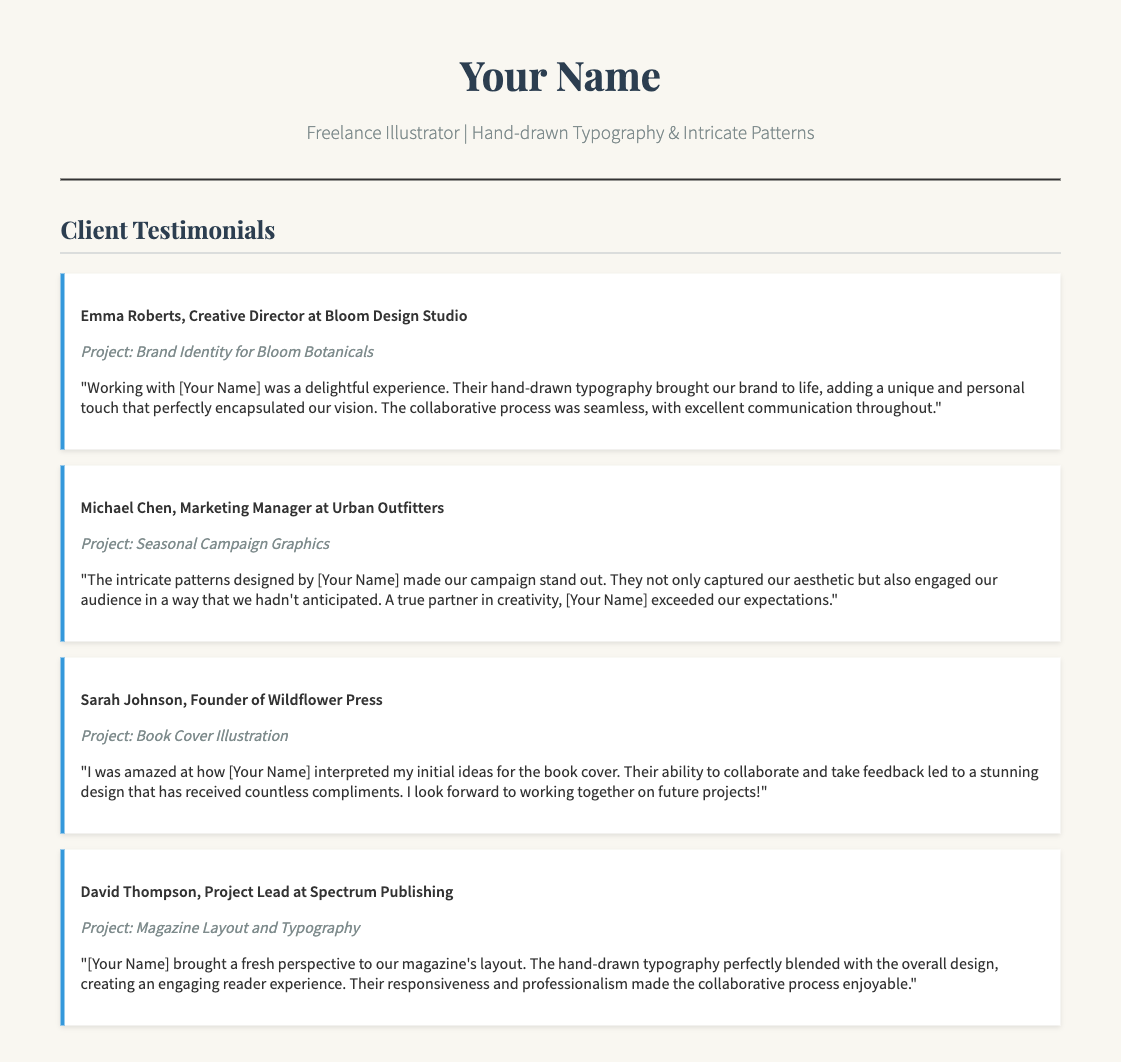what is the name of the first client mentioned? The first client mentioned in the testimonials is Emma Roberts.
Answer: Emma Roberts what is the project associated with Michael Chen? The project associated with Michael Chen is the Seasonal Campaign Graphics.
Answer: Seasonal Campaign Graphics how was the communication described in Emma Roberts' testimonial? Emma Roberts described the communication as excellent throughout the collaborative process.
Answer: excellent what design element did Sarah Johnson compliment in her feedback? Sarah Johnson complimented the stunning design of the book cover illustration.
Answer: stunning design how did David Thompson perceive the collaborative process? David Thompson found the collaborative process enjoyable due to responsiveness and professionalism.
Answer: enjoyable what type of design work was done for Wildflower Press? The type of design work done for Wildflower Press was book cover illustration.
Answer: book cover illustration which project involved intricate patterns according to a testimonial? The project that involved intricate patterns was for Urban Outfitters.
Answer: Seasonal Campaign Graphics who is the Founder of Wildflower Press? The Founder of Wildflower Press is Sarah Johnson.
Answer: Sarah Johnson 